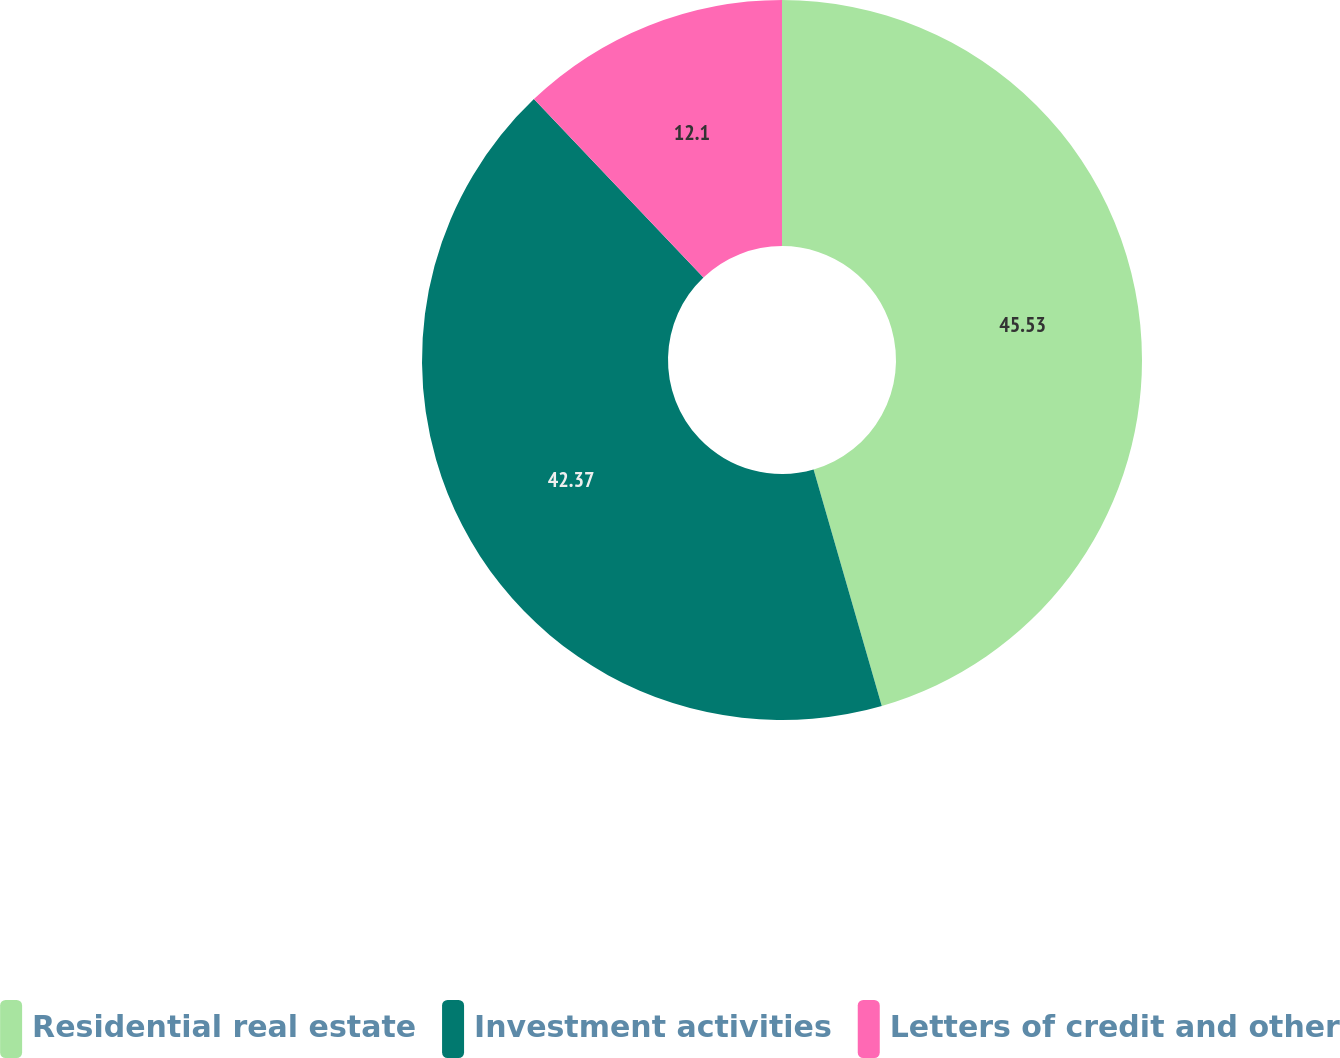Convert chart to OTSL. <chart><loc_0><loc_0><loc_500><loc_500><pie_chart><fcel>Residential real estate<fcel>Investment activities<fcel>Letters of credit and other<nl><fcel>45.53%<fcel>42.37%<fcel>12.1%<nl></chart> 